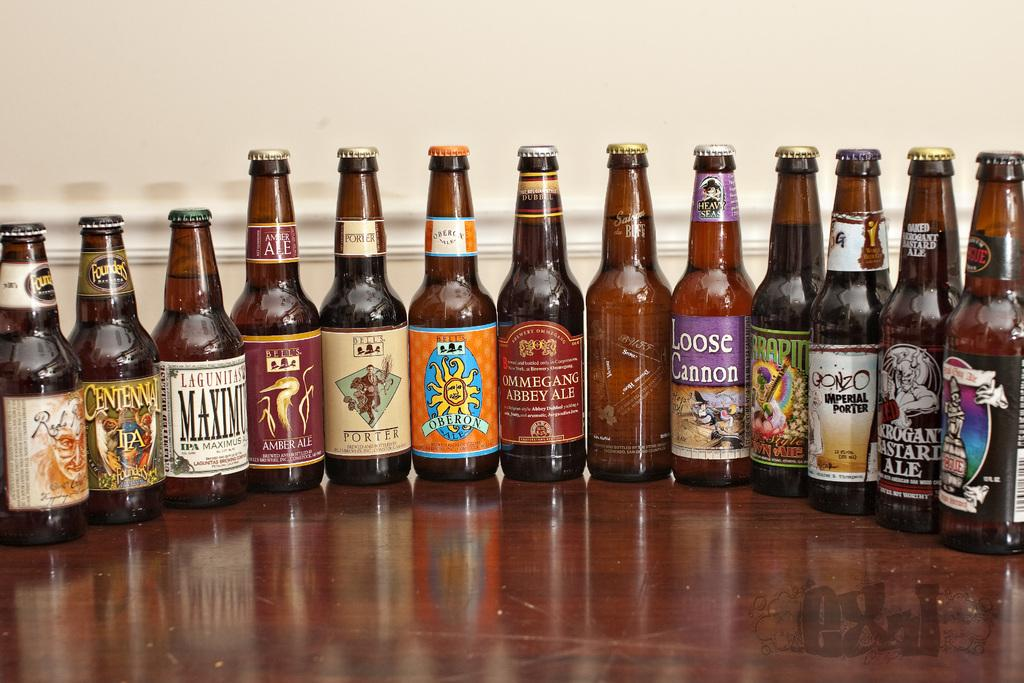<image>
Summarize the visual content of the image. A row of beer bottles including Loose Cannon and Arrogant Bastard Ale. 